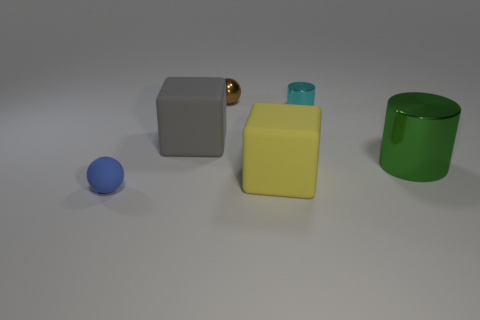Add 2 yellow matte cubes. How many objects exist? 8 Subtract all gray blocks. How many blocks are left? 1 Subtract all cylinders. How many objects are left? 4 Subtract 2 cylinders. How many cylinders are left? 0 Subtract all large green metallic cylinders. Subtract all large gray things. How many objects are left? 4 Add 1 yellow blocks. How many yellow blocks are left? 2 Add 1 tiny red rubber blocks. How many tiny red rubber blocks exist? 1 Subtract 0 red cubes. How many objects are left? 6 Subtract all green balls. Subtract all blue cubes. How many balls are left? 2 